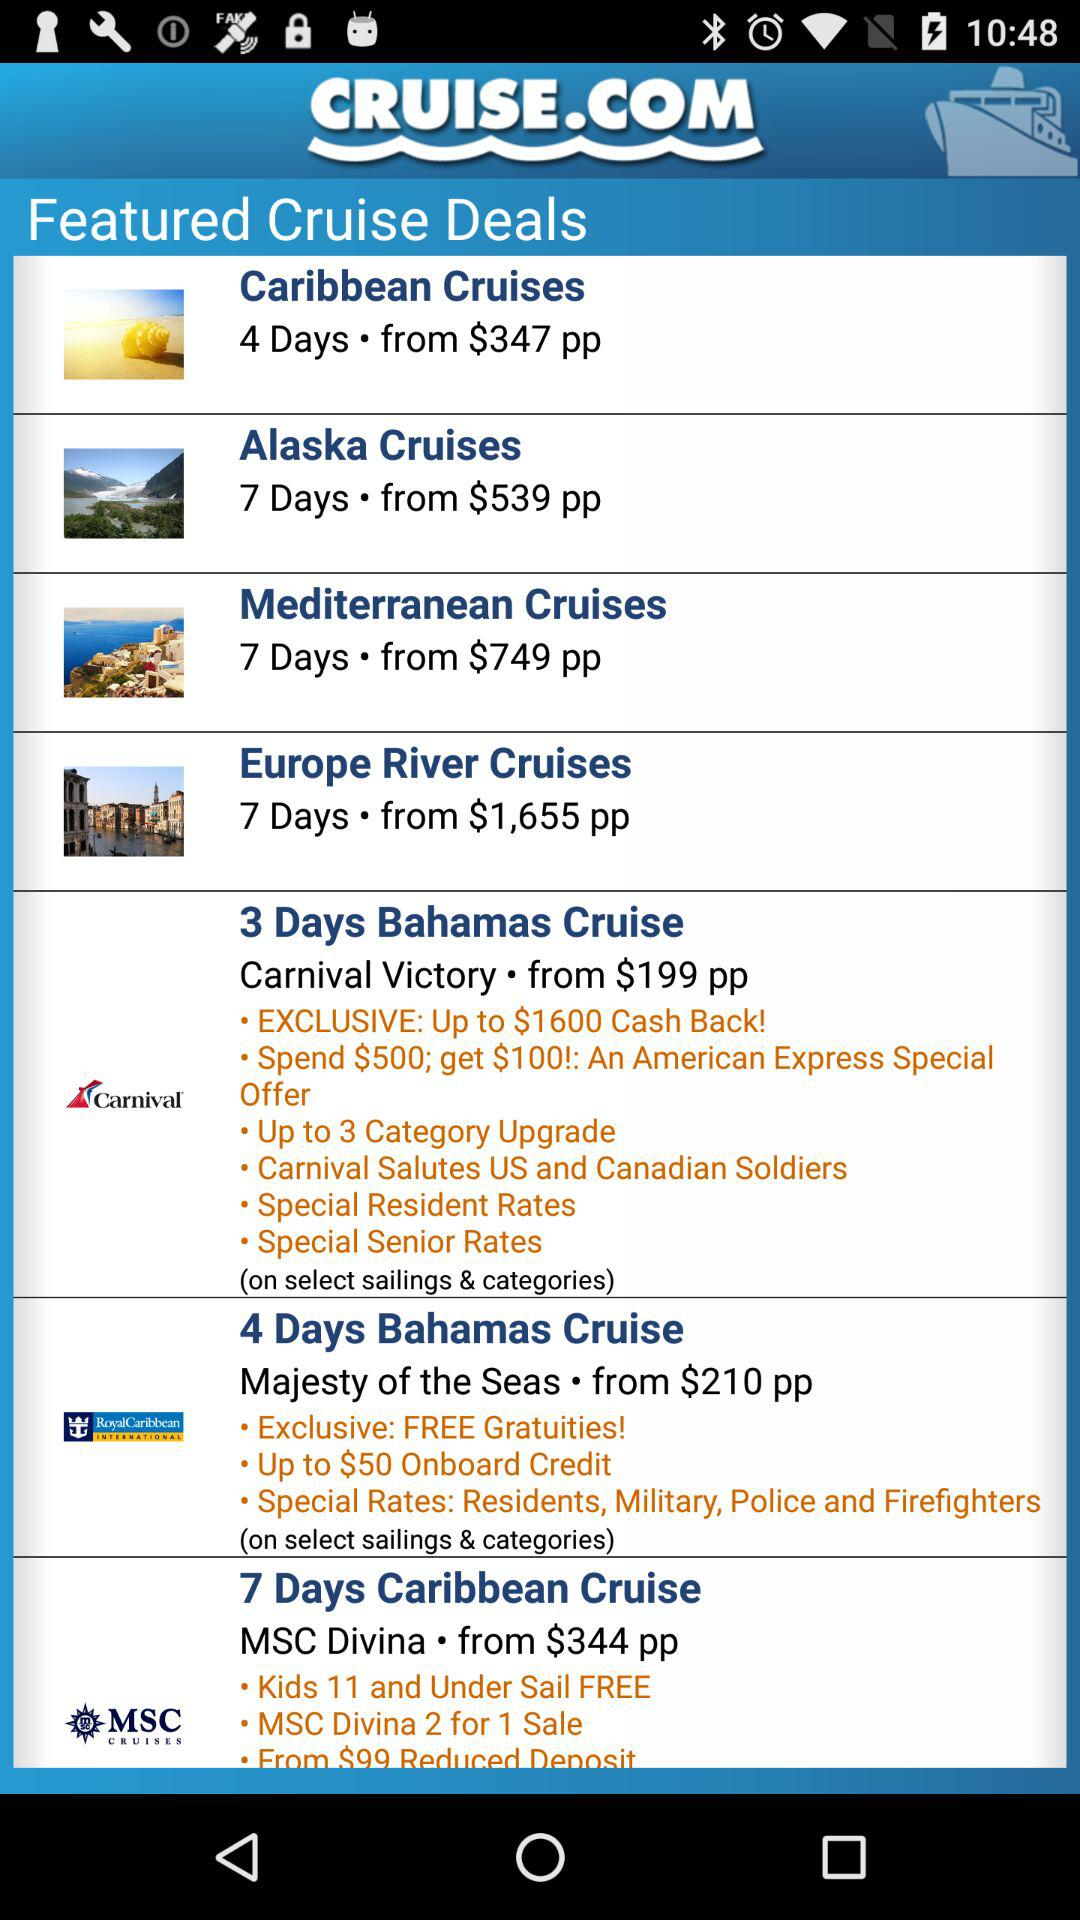What's the price of "Europe River Cruises"? The price of "Europe River Cruises" starts at $1,655 per person. 